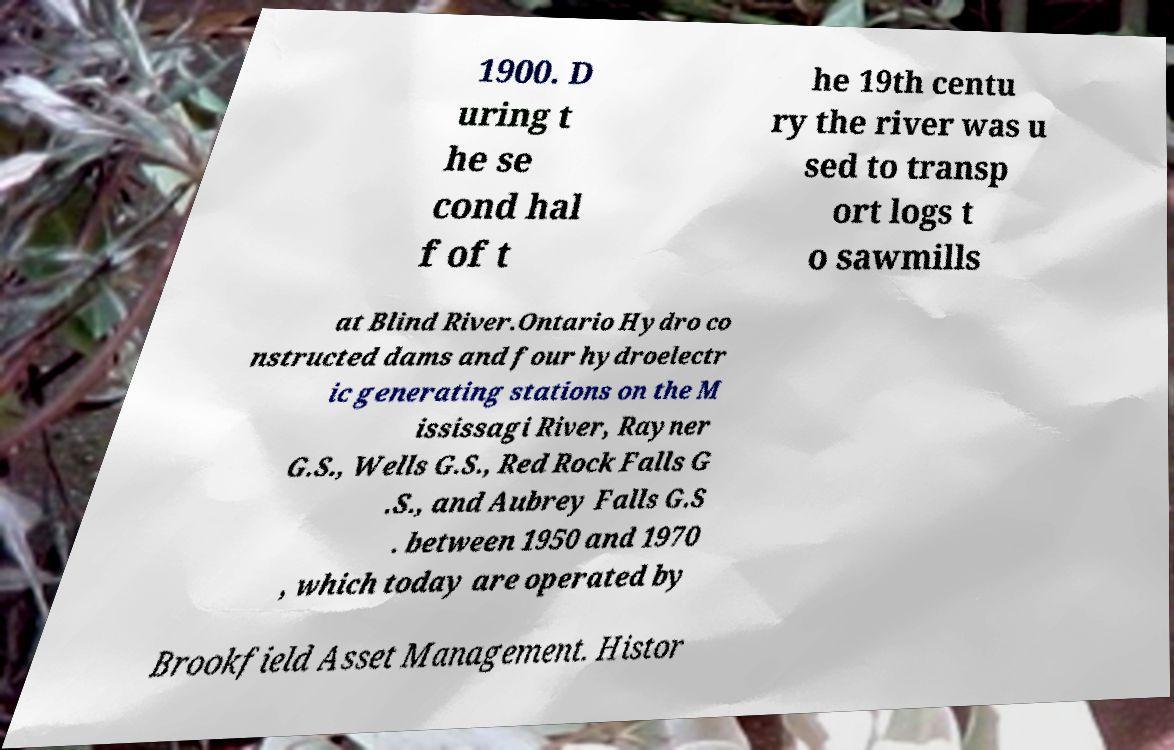What messages or text are displayed in this image? I need them in a readable, typed format. 1900. D uring t he se cond hal f of t he 19th centu ry the river was u sed to transp ort logs t o sawmills at Blind River.Ontario Hydro co nstructed dams and four hydroelectr ic generating stations on the M ississagi River, Rayner G.S., Wells G.S., Red Rock Falls G .S., and Aubrey Falls G.S . between 1950 and 1970 , which today are operated by Brookfield Asset Management. Histor 